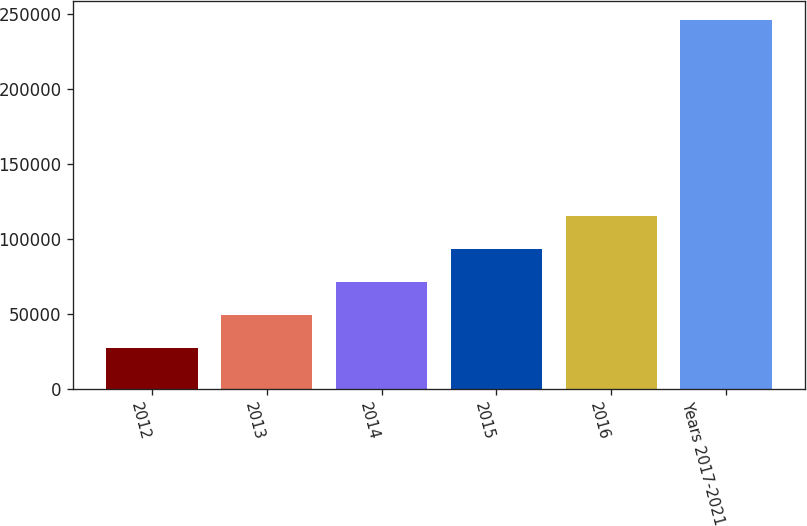<chart> <loc_0><loc_0><loc_500><loc_500><bar_chart><fcel>2012<fcel>2013<fcel>2014<fcel>2015<fcel>2016<fcel>Years 2017-2021<nl><fcel>27610<fcel>49458.1<fcel>71306.2<fcel>93154.3<fcel>115002<fcel>246091<nl></chart> 